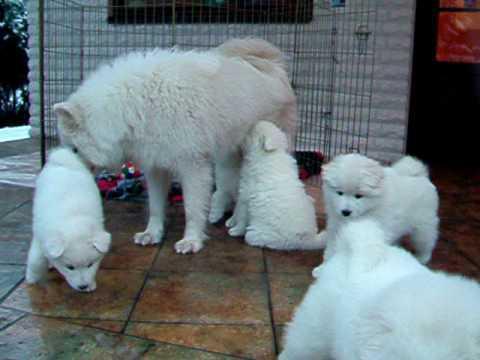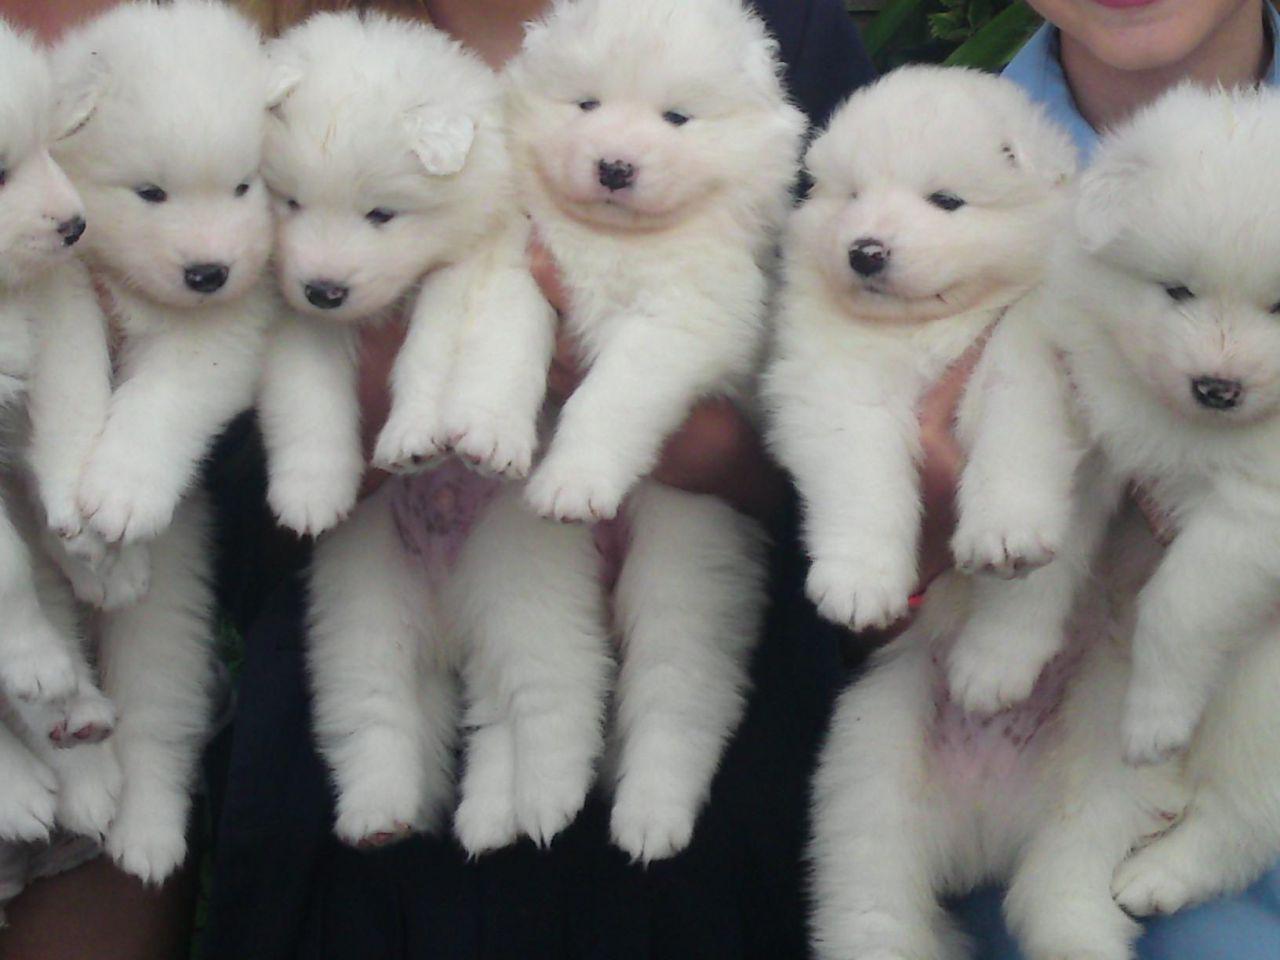The first image is the image on the left, the second image is the image on the right. Examine the images to the left and right. Is the description "Hands are holding up at least five white puppies in one image." accurate? Answer yes or no. Yes. The first image is the image on the left, the second image is the image on the right. For the images shown, is this caption "There is no more than one white dog in the right image." true? Answer yes or no. No. 